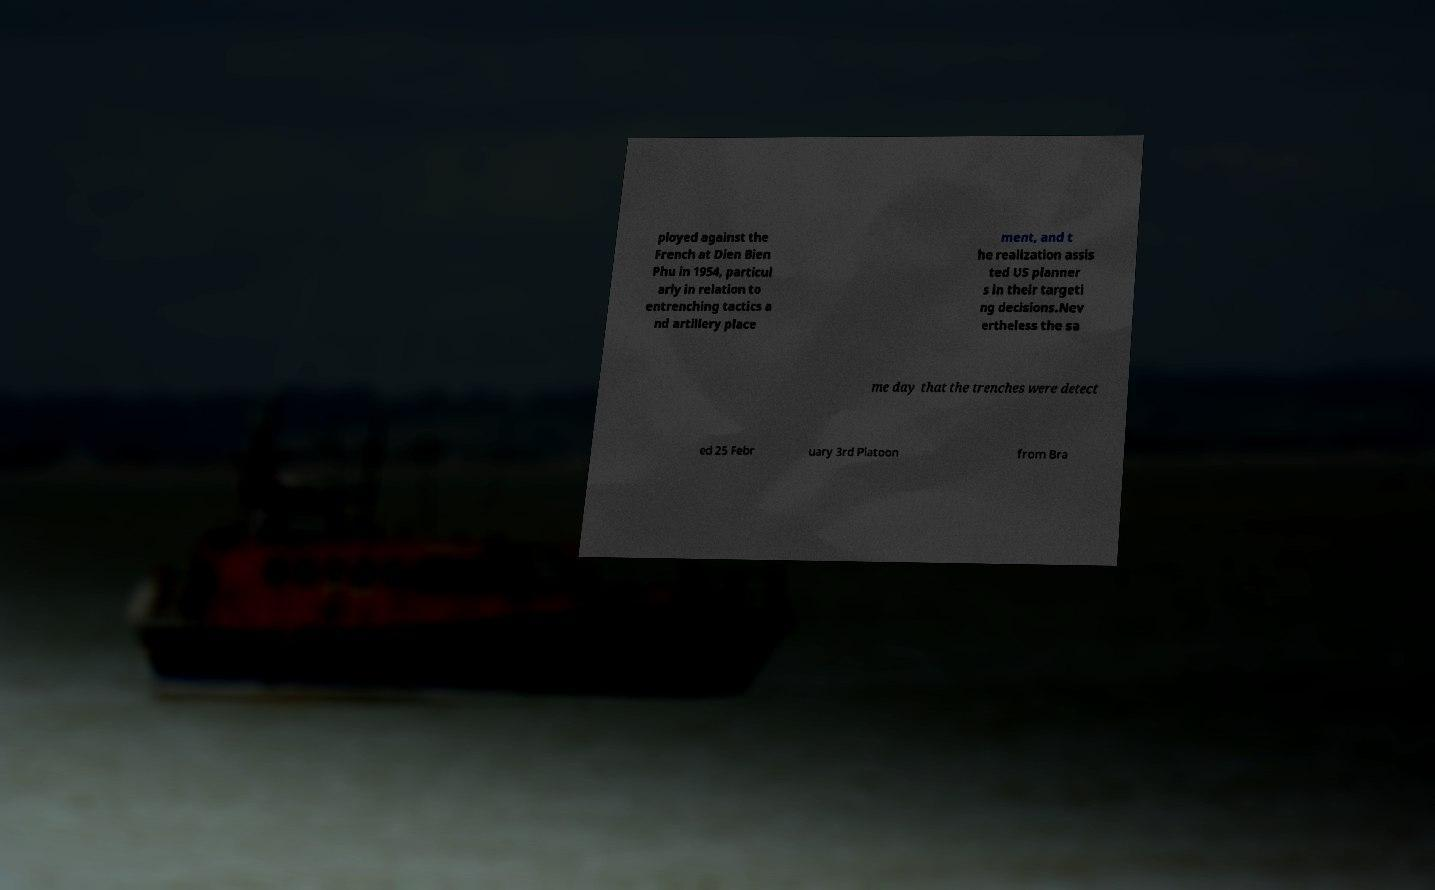What messages or text are displayed in this image? I need them in a readable, typed format. ployed against the French at Dien Bien Phu in 1954, particul arly in relation to entrenching tactics a nd artillery place ment, and t he realization assis ted US planner s in their targeti ng decisions.Nev ertheless the sa me day that the trenches were detect ed 25 Febr uary 3rd Platoon from Bra 